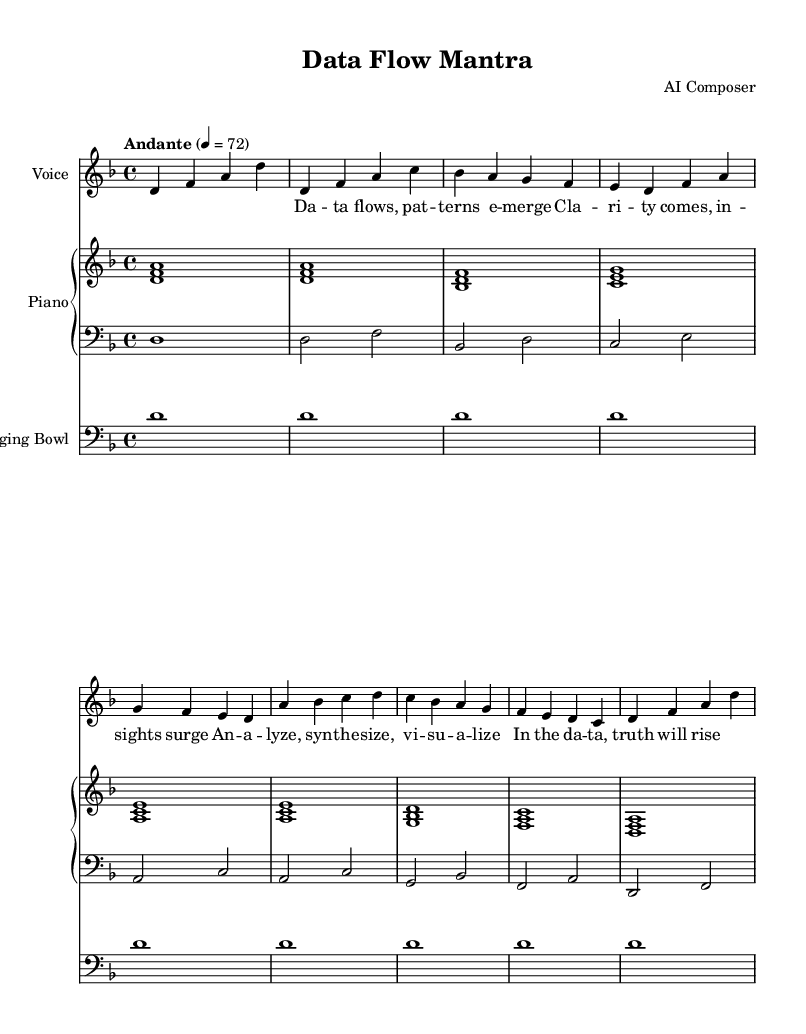What is the key signature of this music? The key signature shown on the left of the staff indicates one flat (B♭), which means it is in D minor.
Answer: D minor What is the time signature of this music? The time signature is represented at the beginning of the staff as 4 over 4, which means there are four beats per measure and the quarter note gets one beat.
Answer: 4/4 What is the tempo marking of this piece? The tempo marking is located at the beginning of the score and is labeled "Andante," which suggests a moderate walking pace, indicated with a metronome marking of 72 beats per minute.
Answer: Andante How many measures are in Chant A? Chant A spans the measures indicated; counting from the intro, there are four measures in Chant A and it ends before Chant B begins.
Answer: 4 What thematic words are used in Chant A? The lyrics in Chant A focus on the flow of data and the emergence of clarity, highlighting concepts of understanding and insight as the themes.
Answer: Data flows, clarity comes What is the purpose of the singing bowl in this piece? The singing bowl part consists of whole notes played on the first beat of each measure, serving as a meditative grounding element throughout the music.
Answer: Grounding element What is the total length of the piece in measures? By counting all the individual measures from the introduction through both chants, the total length sums up to eight measures.
Answer: 8 